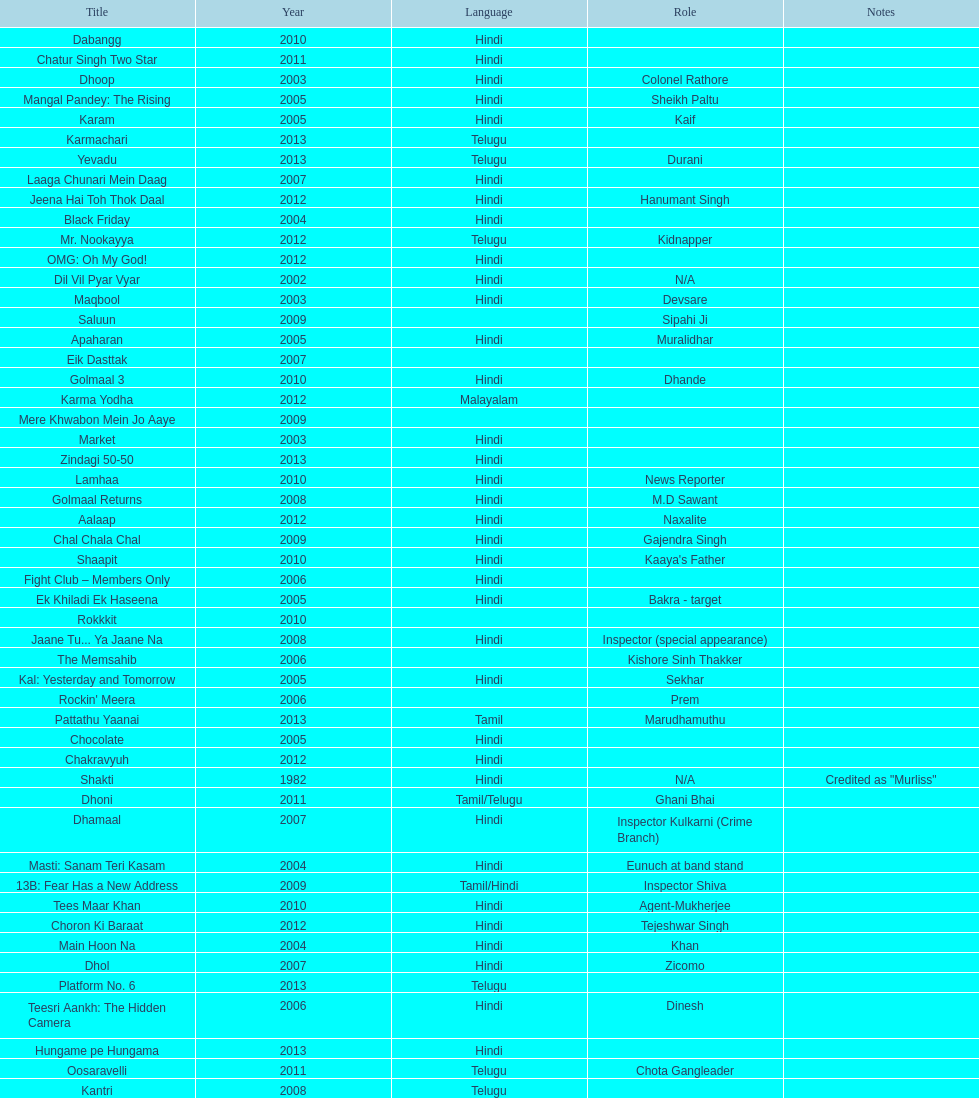What are the number of titles listed in 2005? 6. 